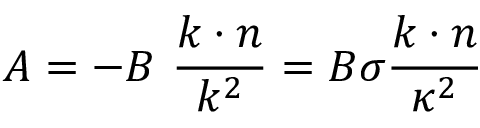<formula> <loc_0><loc_0><loc_500><loc_500>A = - B \ \frac { k \cdot n } { k ^ { 2 } } = B \sigma \frac { k \cdot n } { \kappa ^ { 2 } }</formula> 